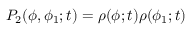Convert formula to latex. <formula><loc_0><loc_0><loc_500><loc_500>P _ { 2 } ( \phi , \phi _ { 1 } ; t ) = \rho ( \phi ; t ) \rho ( \phi _ { 1 } ; t )</formula> 